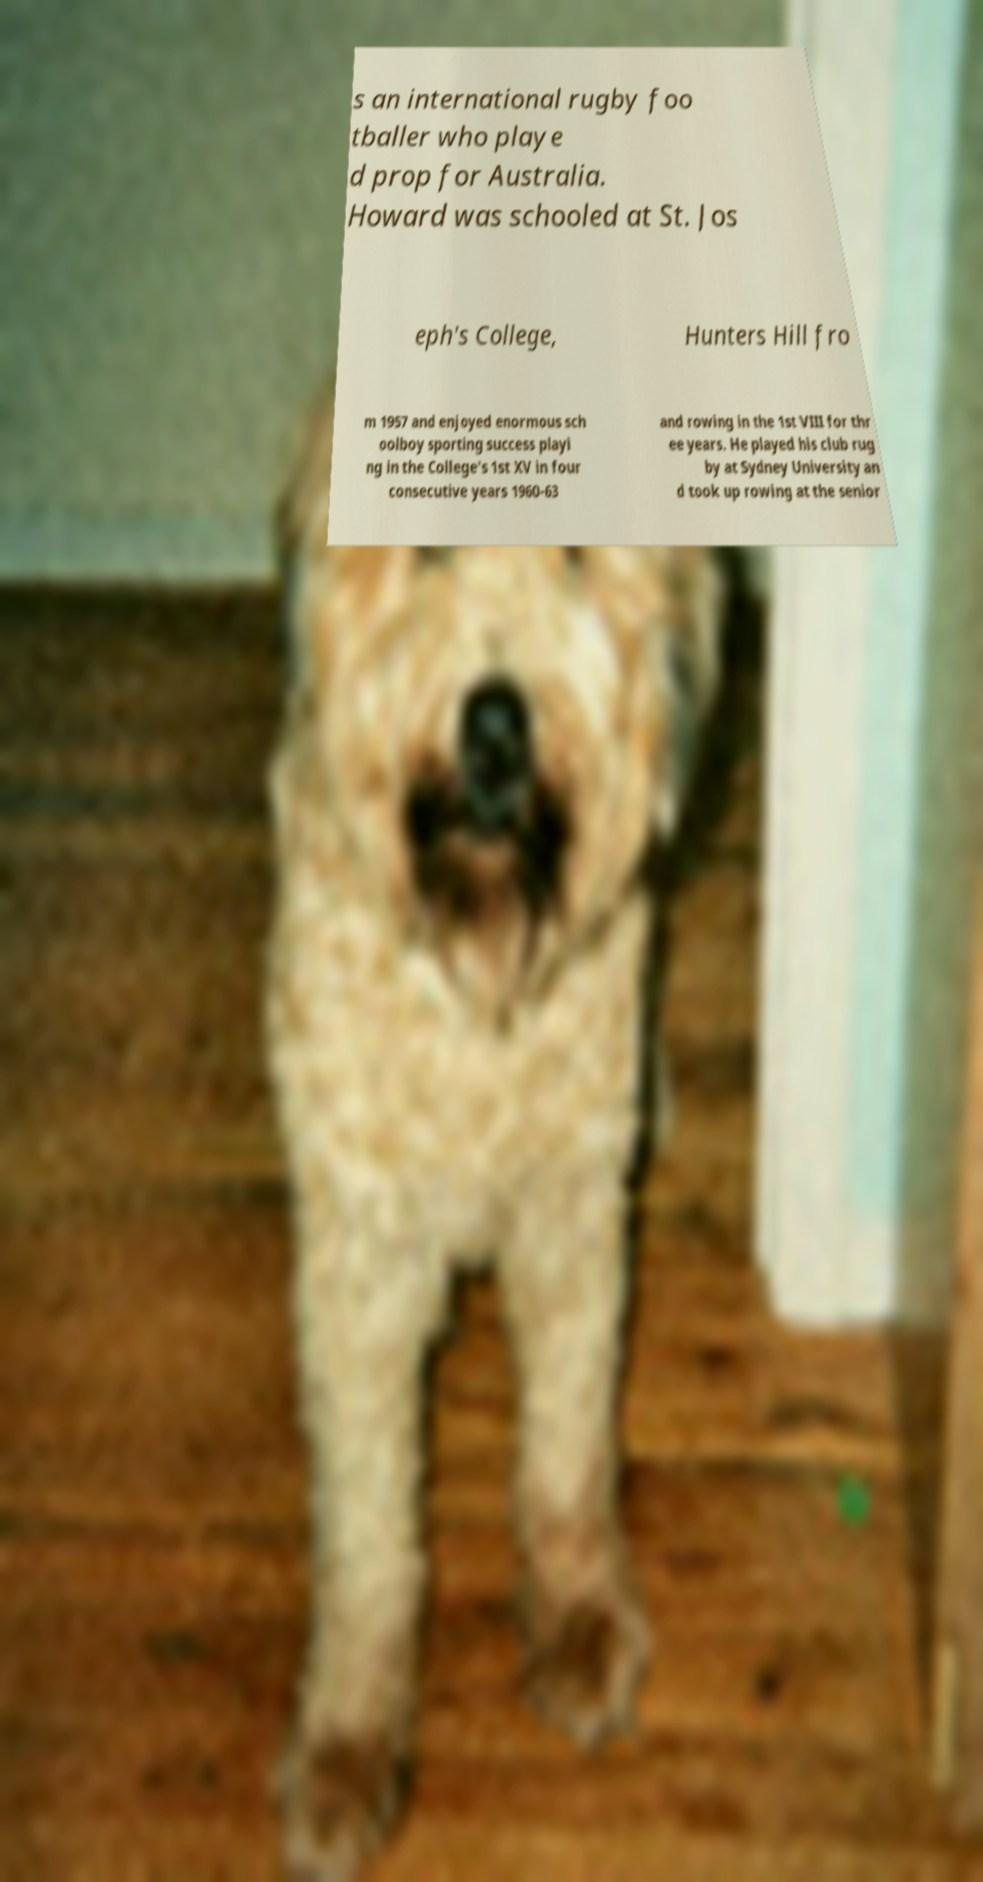There's text embedded in this image that I need extracted. Can you transcribe it verbatim? s an international rugby foo tballer who playe d prop for Australia. Howard was schooled at St. Jos eph's College, Hunters Hill fro m 1957 and enjoyed enormous sch oolboy sporting success playi ng in the College's 1st XV in four consecutive years 1960-63 and rowing in the 1st VIII for thr ee years. He played his club rug by at Sydney University an d took up rowing at the senior 